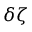<formula> <loc_0><loc_0><loc_500><loc_500>\delta \zeta</formula> 